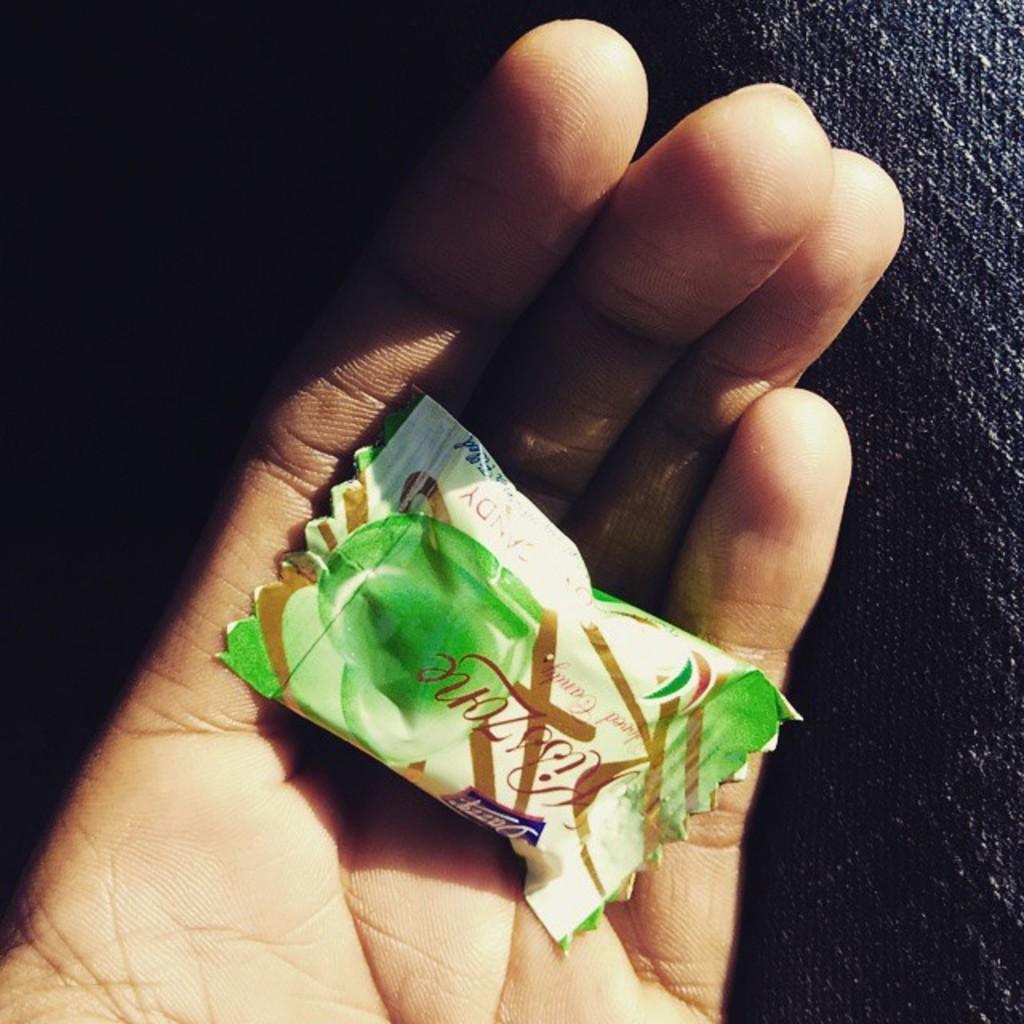Can you describe this image briefly? In this image there is a hand. In the hand there is a chocolate. On the right side it looks like a cloth. 